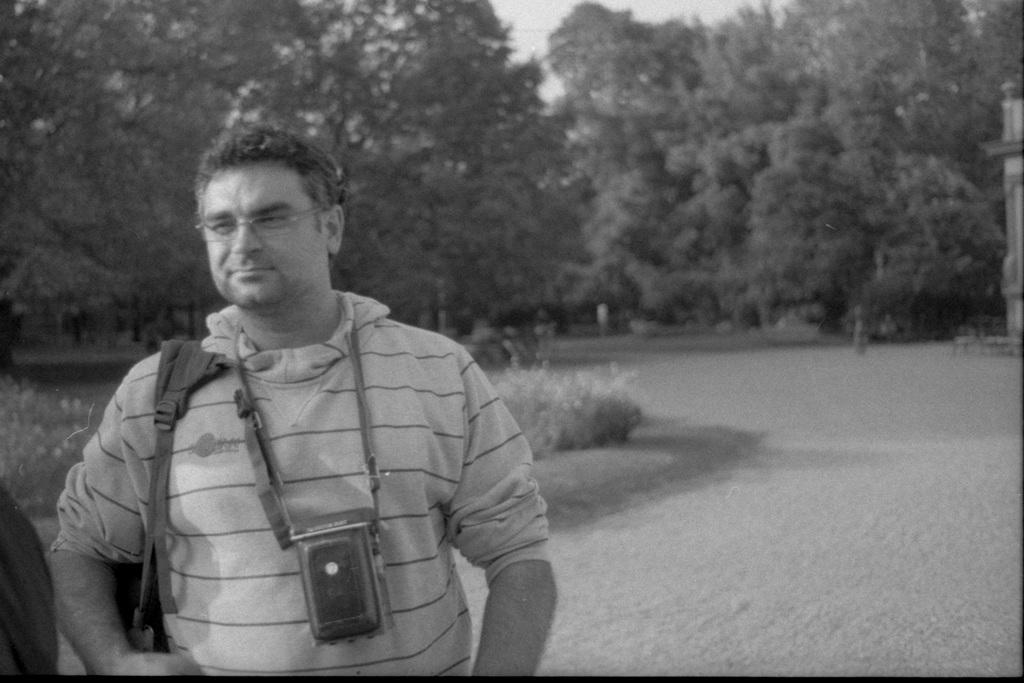What is the main subject of the image? There is a person in the image. What is the person wearing? The person is wearing a camera. What else is the person carrying? The person is carrying a bag. What is the person's facial expression? The person is smiling. What can be seen in the background of the image? There are trees visible in the background of the image. Can you tell me how many snakes are slithering around the person's feet in the image? There are no snakes present in the image; the person is standing among trees. What type of love is being expressed by the person in the image? The image does not convey any specific type of love; it simply shows a person smiling. 